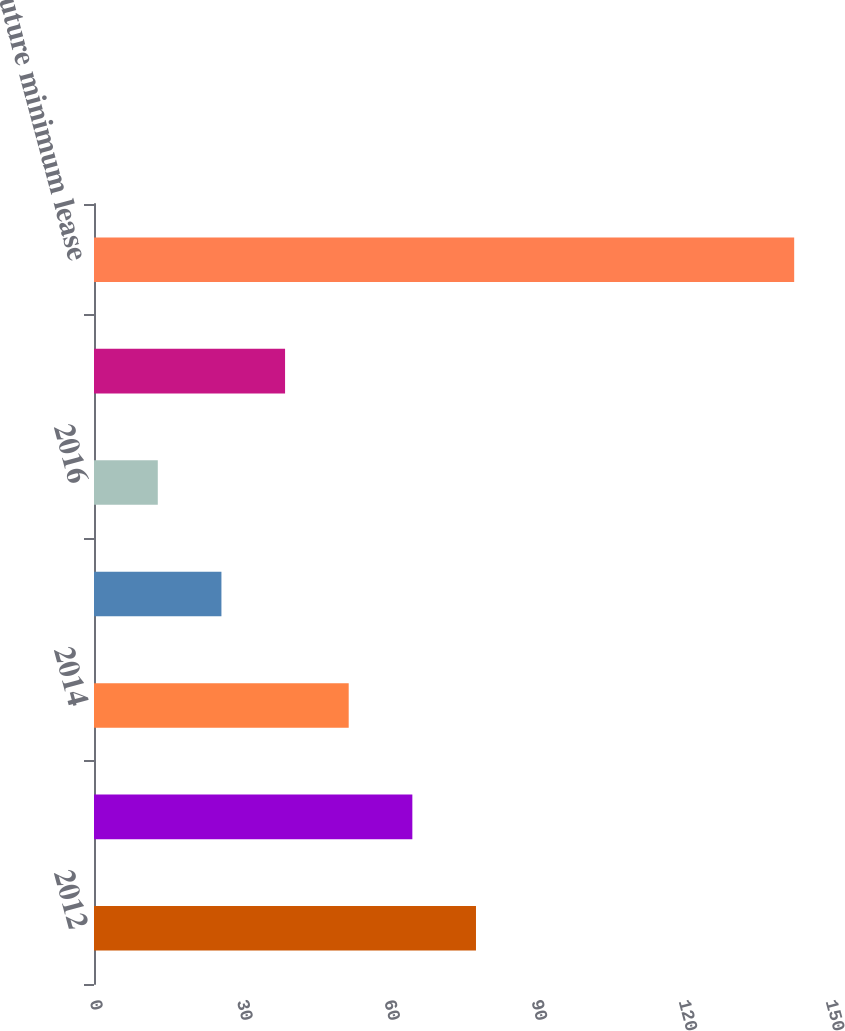Convert chart to OTSL. <chart><loc_0><loc_0><loc_500><loc_500><bar_chart><fcel>2012<fcel>2013<fcel>2014<fcel>2015<fcel>2016<fcel>Thereafter<fcel>Total future minimum lease<nl><fcel>77.85<fcel>64.88<fcel>51.91<fcel>25.97<fcel>13<fcel>38.94<fcel>142.7<nl></chart> 